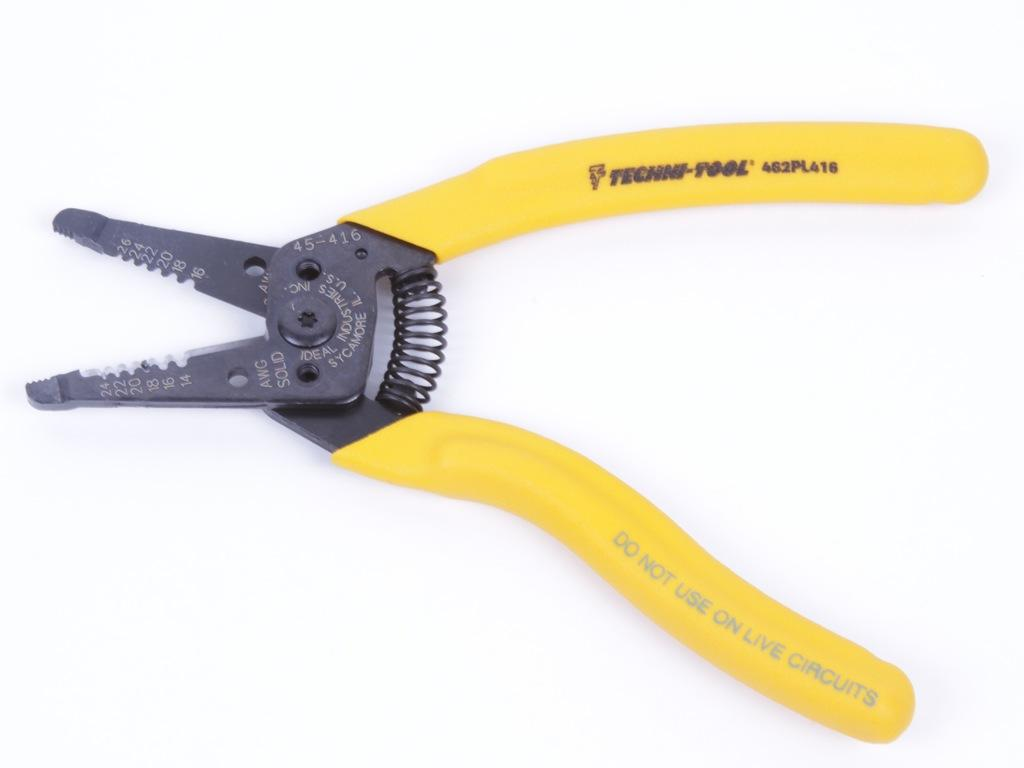<image>
Summarize the visual content of the image. A pair of wire clippers that have do not use on live circuits written on the handle. 